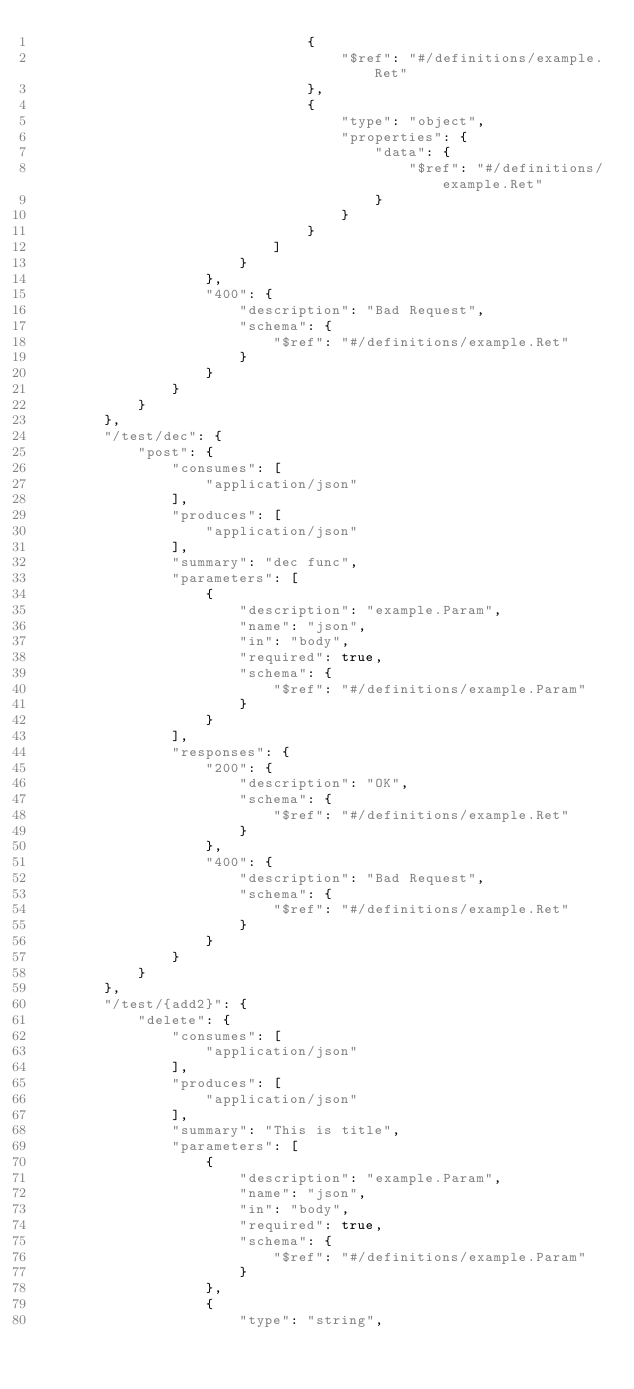<code> <loc_0><loc_0><loc_500><loc_500><_Go_>                                {
                                    "$ref": "#/definitions/example.Ret"
                                },
                                {
                                    "type": "object",
                                    "properties": {
                                        "data": {
                                            "$ref": "#/definitions/example.Ret"
                                        }
                                    }
                                }
                            ]
                        }
                    },
                    "400": {
                        "description": "Bad Request",
                        "schema": {
                            "$ref": "#/definitions/example.Ret"
                        }
                    }
                }
            }
        },
        "/test/dec": {
            "post": {
                "consumes": [
                    "application/json"
                ],
                "produces": [
                    "application/json"
                ],
                "summary": "dec func",
                "parameters": [
                    {
                        "description": "example.Param",
                        "name": "json",
                        "in": "body",
                        "required": true,
                        "schema": {
                            "$ref": "#/definitions/example.Param"
                        }
                    }
                ],
                "responses": {
                    "200": {
                        "description": "OK",
                        "schema": {
                            "$ref": "#/definitions/example.Ret"
                        }
                    },
                    "400": {
                        "description": "Bad Request",
                        "schema": {
                            "$ref": "#/definitions/example.Ret"
                        }
                    }
                }
            }
        },
        "/test/{add2}": {
            "delete": {
                "consumes": [
                    "application/json"
                ],
                "produces": [
                    "application/json"
                ],
                "summary": "This is title",
                "parameters": [
                    {
                        "description": "example.Param",
                        "name": "json",
                        "in": "body",
                        "required": true,
                        "schema": {
                            "$ref": "#/definitions/example.Param"
                        }
                    },
                    {
                        "type": "string",</code> 